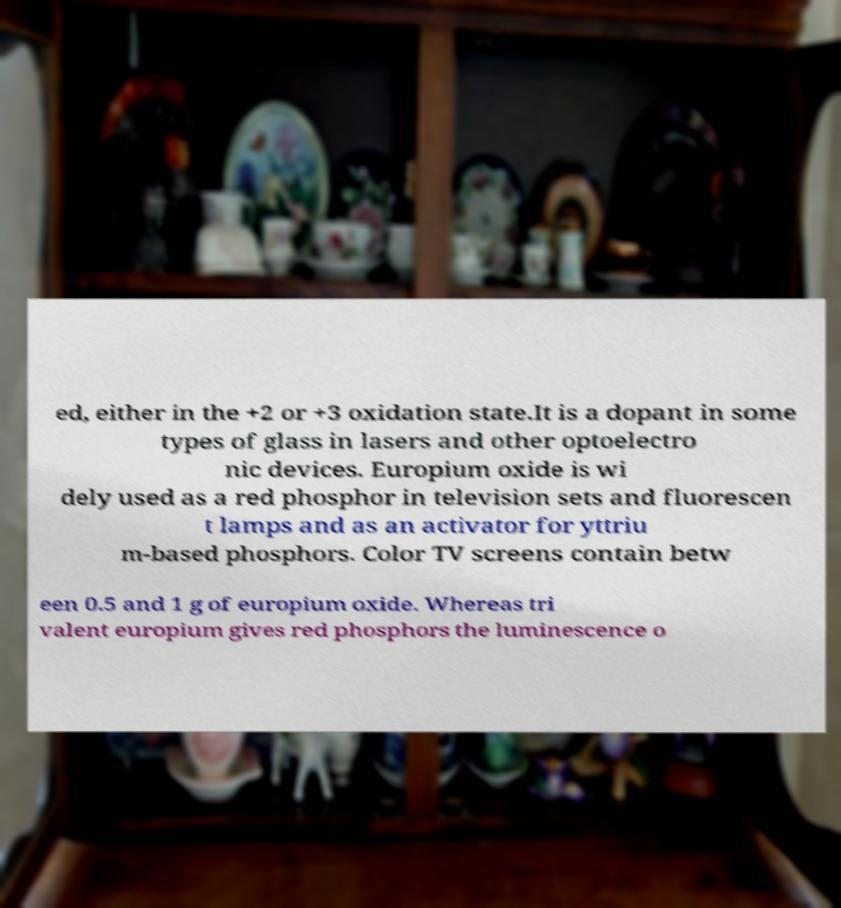Could you extract and type out the text from this image? ed, either in the +2 or +3 oxidation state.It is a dopant in some types of glass in lasers and other optoelectro nic devices. Europium oxide is wi dely used as a red phosphor in television sets and fluorescen t lamps and as an activator for yttriu m-based phosphors. Color TV screens contain betw een 0.5 and 1 g of europium oxide. Whereas tri valent europium gives red phosphors the luminescence o 